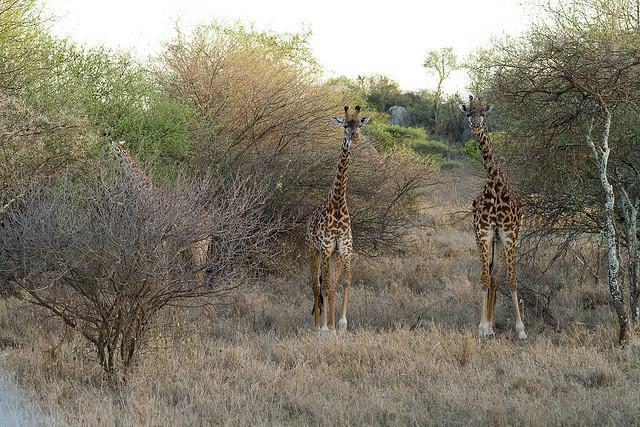How many animals can be seen?
Give a very brief answer. 2. How many animals?
Give a very brief answer. 2. How many zebras are there?
Give a very brief answer. 0. How many giraffes are there?
Give a very brief answer. 2. 